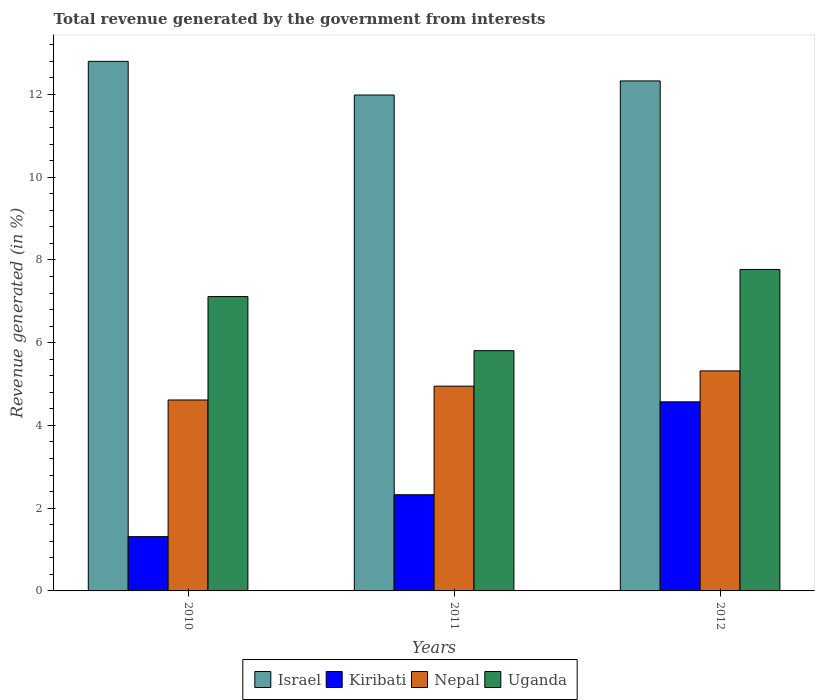How many groups of bars are there?
Make the answer very short. 3. Are the number of bars on each tick of the X-axis equal?
Keep it short and to the point. Yes. How many bars are there on the 1st tick from the right?
Your answer should be compact. 4. What is the total revenue generated in Uganda in 2010?
Keep it short and to the point. 7.11. Across all years, what is the maximum total revenue generated in Kiribati?
Your answer should be very brief. 4.57. Across all years, what is the minimum total revenue generated in Uganda?
Your response must be concise. 5.81. In which year was the total revenue generated in Nepal minimum?
Provide a short and direct response. 2010. What is the total total revenue generated in Kiribati in the graph?
Keep it short and to the point. 8.21. What is the difference between the total revenue generated in Uganda in 2010 and that in 2011?
Offer a terse response. 1.31. What is the difference between the total revenue generated in Israel in 2011 and the total revenue generated in Nepal in 2010?
Your answer should be compact. 7.37. What is the average total revenue generated in Israel per year?
Provide a succinct answer. 12.37. In the year 2011, what is the difference between the total revenue generated in Uganda and total revenue generated in Israel?
Offer a very short reply. -6.18. What is the ratio of the total revenue generated in Uganda in 2011 to that in 2012?
Provide a succinct answer. 0.75. What is the difference between the highest and the second highest total revenue generated in Israel?
Provide a short and direct response. 0.47. What is the difference between the highest and the lowest total revenue generated in Nepal?
Provide a succinct answer. 0.7. Is the sum of the total revenue generated in Nepal in 2010 and 2012 greater than the maximum total revenue generated in Uganda across all years?
Make the answer very short. Yes. Is it the case that in every year, the sum of the total revenue generated in Israel and total revenue generated in Uganda is greater than the sum of total revenue generated in Kiribati and total revenue generated in Nepal?
Provide a succinct answer. No. What does the 2nd bar from the left in 2011 represents?
Provide a succinct answer. Kiribati. What does the 1st bar from the right in 2011 represents?
Your response must be concise. Uganda. Is it the case that in every year, the sum of the total revenue generated in Nepal and total revenue generated in Uganda is greater than the total revenue generated in Israel?
Ensure brevity in your answer.  No. Are all the bars in the graph horizontal?
Your answer should be compact. No. How many years are there in the graph?
Give a very brief answer. 3. What is the difference between two consecutive major ticks on the Y-axis?
Provide a short and direct response. 2. Does the graph contain any zero values?
Make the answer very short. No. What is the title of the graph?
Offer a terse response. Total revenue generated by the government from interests. What is the label or title of the X-axis?
Give a very brief answer. Years. What is the label or title of the Y-axis?
Ensure brevity in your answer.  Revenue generated (in %). What is the Revenue generated (in %) in Israel in 2010?
Make the answer very short. 12.8. What is the Revenue generated (in %) in Kiribati in 2010?
Keep it short and to the point. 1.31. What is the Revenue generated (in %) of Nepal in 2010?
Provide a short and direct response. 4.62. What is the Revenue generated (in %) in Uganda in 2010?
Offer a terse response. 7.11. What is the Revenue generated (in %) of Israel in 2011?
Offer a terse response. 11.99. What is the Revenue generated (in %) in Kiribati in 2011?
Make the answer very short. 2.33. What is the Revenue generated (in %) of Nepal in 2011?
Offer a terse response. 4.95. What is the Revenue generated (in %) of Uganda in 2011?
Provide a short and direct response. 5.81. What is the Revenue generated (in %) of Israel in 2012?
Provide a succinct answer. 12.33. What is the Revenue generated (in %) in Kiribati in 2012?
Offer a very short reply. 4.57. What is the Revenue generated (in %) of Nepal in 2012?
Make the answer very short. 5.32. What is the Revenue generated (in %) of Uganda in 2012?
Give a very brief answer. 7.77. Across all years, what is the maximum Revenue generated (in %) in Israel?
Give a very brief answer. 12.8. Across all years, what is the maximum Revenue generated (in %) of Kiribati?
Your answer should be compact. 4.57. Across all years, what is the maximum Revenue generated (in %) in Nepal?
Offer a very short reply. 5.32. Across all years, what is the maximum Revenue generated (in %) in Uganda?
Give a very brief answer. 7.77. Across all years, what is the minimum Revenue generated (in %) in Israel?
Your response must be concise. 11.99. Across all years, what is the minimum Revenue generated (in %) in Kiribati?
Give a very brief answer. 1.31. Across all years, what is the minimum Revenue generated (in %) of Nepal?
Your answer should be very brief. 4.62. Across all years, what is the minimum Revenue generated (in %) in Uganda?
Keep it short and to the point. 5.81. What is the total Revenue generated (in %) of Israel in the graph?
Offer a very short reply. 37.12. What is the total Revenue generated (in %) in Kiribati in the graph?
Your answer should be compact. 8.21. What is the total Revenue generated (in %) in Nepal in the graph?
Give a very brief answer. 14.88. What is the total Revenue generated (in %) of Uganda in the graph?
Make the answer very short. 20.69. What is the difference between the Revenue generated (in %) of Israel in 2010 and that in 2011?
Your response must be concise. 0.81. What is the difference between the Revenue generated (in %) of Kiribati in 2010 and that in 2011?
Keep it short and to the point. -1.01. What is the difference between the Revenue generated (in %) in Nepal in 2010 and that in 2011?
Keep it short and to the point. -0.33. What is the difference between the Revenue generated (in %) of Uganda in 2010 and that in 2011?
Keep it short and to the point. 1.31. What is the difference between the Revenue generated (in %) in Israel in 2010 and that in 2012?
Ensure brevity in your answer.  0.47. What is the difference between the Revenue generated (in %) in Kiribati in 2010 and that in 2012?
Ensure brevity in your answer.  -3.26. What is the difference between the Revenue generated (in %) in Nepal in 2010 and that in 2012?
Your answer should be very brief. -0.7. What is the difference between the Revenue generated (in %) in Uganda in 2010 and that in 2012?
Provide a short and direct response. -0.66. What is the difference between the Revenue generated (in %) in Israel in 2011 and that in 2012?
Give a very brief answer. -0.34. What is the difference between the Revenue generated (in %) of Kiribati in 2011 and that in 2012?
Your response must be concise. -2.25. What is the difference between the Revenue generated (in %) in Nepal in 2011 and that in 2012?
Make the answer very short. -0.37. What is the difference between the Revenue generated (in %) of Uganda in 2011 and that in 2012?
Make the answer very short. -1.96. What is the difference between the Revenue generated (in %) of Israel in 2010 and the Revenue generated (in %) of Kiribati in 2011?
Your answer should be very brief. 10.48. What is the difference between the Revenue generated (in %) in Israel in 2010 and the Revenue generated (in %) in Nepal in 2011?
Your answer should be compact. 7.85. What is the difference between the Revenue generated (in %) of Israel in 2010 and the Revenue generated (in %) of Uganda in 2011?
Offer a terse response. 6.99. What is the difference between the Revenue generated (in %) of Kiribati in 2010 and the Revenue generated (in %) of Nepal in 2011?
Your response must be concise. -3.64. What is the difference between the Revenue generated (in %) in Kiribati in 2010 and the Revenue generated (in %) in Uganda in 2011?
Give a very brief answer. -4.5. What is the difference between the Revenue generated (in %) of Nepal in 2010 and the Revenue generated (in %) of Uganda in 2011?
Ensure brevity in your answer.  -1.19. What is the difference between the Revenue generated (in %) in Israel in 2010 and the Revenue generated (in %) in Kiribati in 2012?
Keep it short and to the point. 8.23. What is the difference between the Revenue generated (in %) of Israel in 2010 and the Revenue generated (in %) of Nepal in 2012?
Make the answer very short. 7.48. What is the difference between the Revenue generated (in %) of Israel in 2010 and the Revenue generated (in %) of Uganda in 2012?
Your response must be concise. 5.03. What is the difference between the Revenue generated (in %) of Kiribati in 2010 and the Revenue generated (in %) of Nepal in 2012?
Your answer should be very brief. -4.01. What is the difference between the Revenue generated (in %) in Kiribati in 2010 and the Revenue generated (in %) in Uganda in 2012?
Your answer should be very brief. -6.46. What is the difference between the Revenue generated (in %) in Nepal in 2010 and the Revenue generated (in %) in Uganda in 2012?
Provide a succinct answer. -3.16. What is the difference between the Revenue generated (in %) of Israel in 2011 and the Revenue generated (in %) of Kiribati in 2012?
Your answer should be compact. 7.42. What is the difference between the Revenue generated (in %) in Israel in 2011 and the Revenue generated (in %) in Nepal in 2012?
Give a very brief answer. 6.67. What is the difference between the Revenue generated (in %) of Israel in 2011 and the Revenue generated (in %) of Uganda in 2012?
Your answer should be very brief. 4.22. What is the difference between the Revenue generated (in %) of Kiribati in 2011 and the Revenue generated (in %) of Nepal in 2012?
Offer a terse response. -2.99. What is the difference between the Revenue generated (in %) in Kiribati in 2011 and the Revenue generated (in %) in Uganda in 2012?
Offer a terse response. -5.45. What is the difference between the Revenue generated (in %) of Nepal in 2011 and the Revenue generated (in %) of Uganda in 2012?
Provide a succinct answer. -2.82. What is the average Revenue generated (in %) of Israel per year?
Your answer should be very brief. 12.37. What is the average Revenue generated (in %) of Kiribati per year?
Provide a succinct answer. 2.74. What is the average Revenue generated (in %) in Nepal per year?
Ensure brevity in your answer.  4.96. What is the average Revenue generated (in %) of Uganda per year?
Provide a succinct answer. 6.9. In the year 2010, what is the difference between the Revenue generated (in %) of Israel and Revenue generated (in %) of Kiribati?
Provide a short and direct response. 11.49. In the year 2010, what is the difference between the Revenue generated (in %) in Israel and Revenue generated (in %) in Nepal?
Offer a terse response. 8.19. In the year 2010, what is the difference between the Revenue generated (in %) in Israel and Revenue generated (in %) in Uganda?
Your answer should be very brief. 5.69. In the year 2010, what is the difference between the Revenue generated (in %) of Kiribati and Revenue generated (in %) of Nepal?
Your answer should be compact. -3.3. In the year 2010, what is the difference between the Revenue generated (in %) of Kiribati and Revenue generated (in %) of Uganda?
Keep it short and to the point. -5.8. In the year 2010, what is the difference between the Revenue generated (in %) of Nepal and Revenue generated (in %) of Uganda?
Provide a short and direct response. -2.5. In the year 2011, what is the difference between the Revenue generated (in %) of Israel and Revenue generated (in %) of Kiribati?
Make the answer very short. 9.66. In the year 2011, what is the difference between the Revenue generated (in %) in Israel and Revenue generated (in %) in Nepal?
Your response must be concise. 7.04. In the year 2011, what is the difference between the Revenue generated (in %) in Israel and Revenue generated (in %) in Uganda?
Give a very brief answer. 6.18. In the year 2011, what is the difference between the Revenue generated (in %) in Kiribati and Revenue generated (in %) in Nepal?
Give a very brief answer. -2.62. In the year 2011, what is the difference between the Revenue generated (in %) of Kiribati and Revenue generated (in %) of Uganda?
Your answer should be very brief. -3.48. In the year 2011, what is the difference between the Revenue generated (in %) of Nepal and Revenue generated (in %) of Uganda?
Ensure brevity in your answer.  -0.86. In the year 2012, what is the difference between the Revenue generated (in %) in Israel and Revenue generated (in %) in Kiribati?
Your answer should be very brief. 7.76. In the year 2012, what is the difference between the Revenue generated (in %) in Israel and Revenue generated (in %) in Nepal?
Your response must be concise. 7.01. In the year 2012, what is the difference between the Revenue generated (in %) of Israel and Revenue generated (in %) of Uganda?
Make the answer very short. 4.56. In the year 2012, what is the difference between the Revenue generated (in %) in Kiribati and Revenue generated (in %) in Nepal?
Offer a very short reply. -0.75. In the year 2012, what is the difference between the Revenue generated (in %) in Kiribati and Revenue generated (in %) in Uganda?
Ensure brevity in your answer.  -3.2. In the year 2012, what is the difference between the Revenue generated (in %) in Nepal and Revenue generated (in %) in Uganda?
Your answer should be compact. -2.45. What is the ratio of the Revenue generated (in %) of Israel in 2010 to that in 2011?
Provide a succinct answer. 1.07. What is the ratio of the Revenue generated (in %) of Kiribati in 2010 to that in 2011?
Offer a terse response. 0.56. What is the ratio of the Revenue generated (in %) in Nepal in 2010 to that in 2011?
Your response must be concise. 0.93. What is the ratio of the Revenue generated (in %) of Uganda in 2010 to that in 2011?
Provide a succinct answer. 1.23. What is the ratio of the Revenue generated (in %) in Israel in 2010 to that in 2012?
Ensure brevity in your answer.  1.04. What is the ratio of the Revenue generated (in %) of Kiribati in 2010 to that in 2012?
Your response must be concise. 0.29. What is the ratio of the Revenue generated (in %) of Nepal in 2010 to that in 2012?
Offer a terse response. 0.87. What is the ratio of the Revenue generated (in %) in Uganda in 2010 to that in 2012?
Keep it short and to the point. 0.92. What is the ratio of the Revenue generated (in %) in Israel in 2011 to that in 2012?
Your answer should be very brief. 0.97. What is the ratio of the Revenue generated (in %) in Kiribati in 2011 to that in 2012?
Make the answer very short. 0.51. What is the ratio of the Revenue generated (in %) in Nepal in 2011 to that in 2012?
Keep it short and to the point. 0.93. What is the ratio of the Revenue generated (in %) of Uganda in 2011 to that in 2012?
Ensure brevity in your answer.  0.75. What is the difference between the highest and the second highest Revenue generated (in %) of Israel?
Your answer should be compact. 0.47. What is the difference between the highest and the second highest Revenue generated (in %) of Kiribati?
Your response must be concise. 2.25. What is the difference between the highest and the second highest Revenue generated (in %) of Nepal?
Make the answer very short. 0.37. What is the difference between the highest and the second highest Revenue generated (in %) in Uganda?
Give a very brief answer. 0.66. What is the difference between the highest and the lowest Revenue generated (in %) in Israel?
Ensure brevity in your answer.  0.81. What is the difference between the highest and the lowest Revenue generated (in %) of Kiribati?
Provide a short and direct response. 3.26. What is the difference between the highest and the lowest Revenue generated (in %) of Nepal?
Give a very brief answer. 0.7. What is the difference between the highest and the lowest Revenue generated (in %) in Uganda?
Your answer should be very brief. 1.96. 